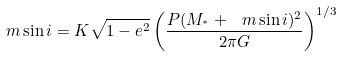<formula> <loc_0><loc_0><loc_500><loc_500>\ m \sin i = K \sqrt { 1 - e ^ { 2 } } \left ( \frac { P ( M _ { ^ { * } } + \ m \sin i ) ^ { 2 } } { 2 \pi G } \right ) ^ { 1 / 3 }</formula> 